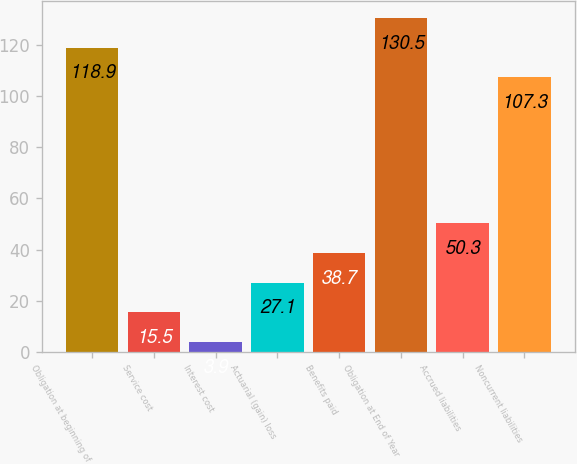Convert chart to OTSL. <chart><loc_0><loc_0><loc_500><loc_500><bar_chart><fcel>Obligation at beginning of<fcel>Service cost<fcel>Interest cost<fcel>Actuarial (gain) loss<fcel>Benefits paid<fcel>Obligation at End of Year<fcel>Accrued liabilities<fcel>Noncurrent liabilities<nl><fcel>118.9<fcel>15.5<fcel>3.9<fcel>27.1<fcel>38.7<fcel>130.5<fcel>50.3<fcel>107.3<nl></chart> 